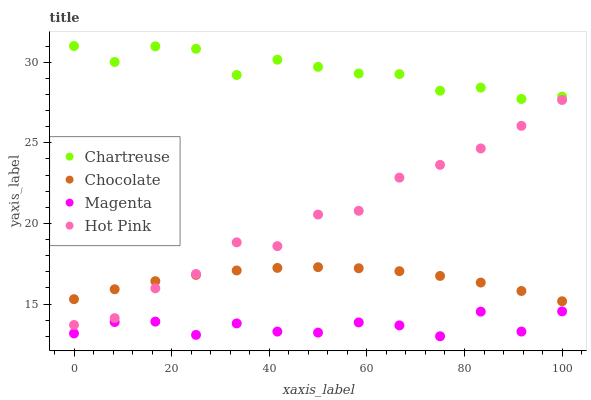Does Magenta have the minimum area under the curve?
Answer yes or no. Yes. Does Chartreuse have the maximum area under the curve?
Answer yes or no. Yes. Does Hot Pink have the minimum area under the curve?
Answer yes or no. No. Does Hot Pink have the maximum area under the curve?
Answer yes or no. No. Is Chocolate the smoothest?
Answer yes or no. Yes. Is Magenta the roughest?
Answer yes or no. Yes. Is Hot Pink the smoothest?
Answer yes or no. No. Is Hot Pink the roughest?
Answer yes or no. No. Does Magenta have the lowest value?
Answer yes or no. Yes. Does Hot Pink have the lowest value?
Answer yes or no. No. Does Chartreuse have the highest value?
Answer yes or no. Yes. Does Hot Pink have the highest value?
Answer yes or no. No. Is Chocolate less than Chartreuse?
Answer yes or no. Yes. Is Hot Pink greater than Magenta?
Answer yes or no. Yes. Does Chocolate intersect Hot Pink?
Answer yes or no. Yes. Is Chocolate less than Hot Pink?
Answer yes or no. No. Is Chocolate greater than Hot Pink?
Answer yes or no. No. Does Chocolate intersect Chartreuse?
Answer yes or no. No. 